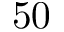<formula> <loc_0><loc_0><loc_500><loc_500>5 0</formula> 